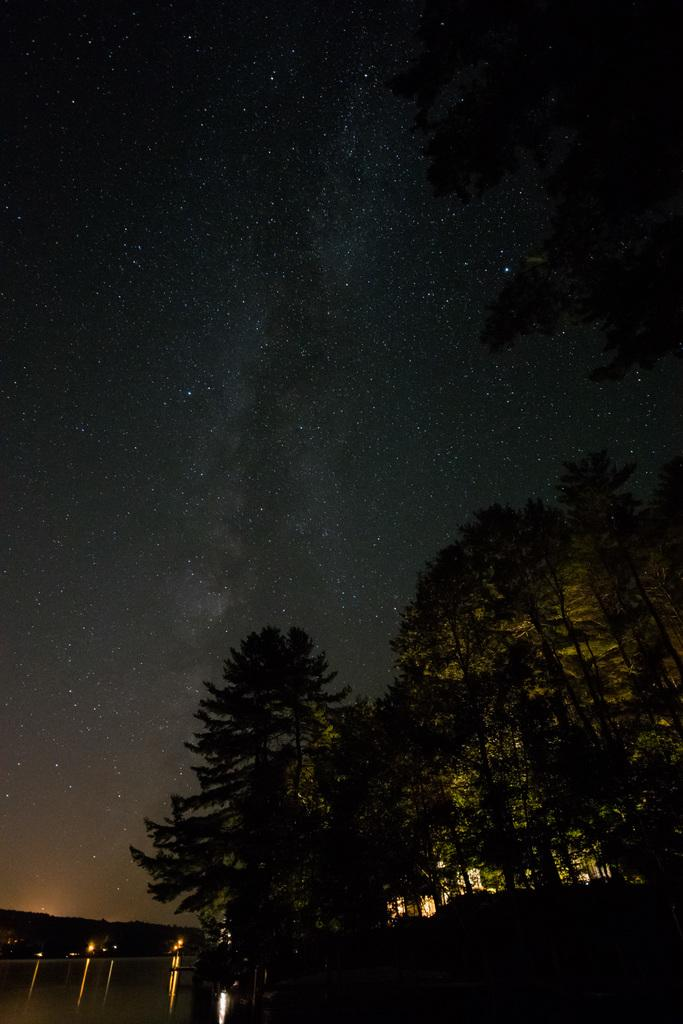What type of vegetation can be seen in the image? There are trees in the image. What natural feature is visible in the image? There is a water surface visible in the image. What celestial objects can be seen in the sky at the top of the image? Stars are visible in the sky at the top of the image. What is the value of the girl's bee collection in the image? There is no girl or bee collection present in the image. 